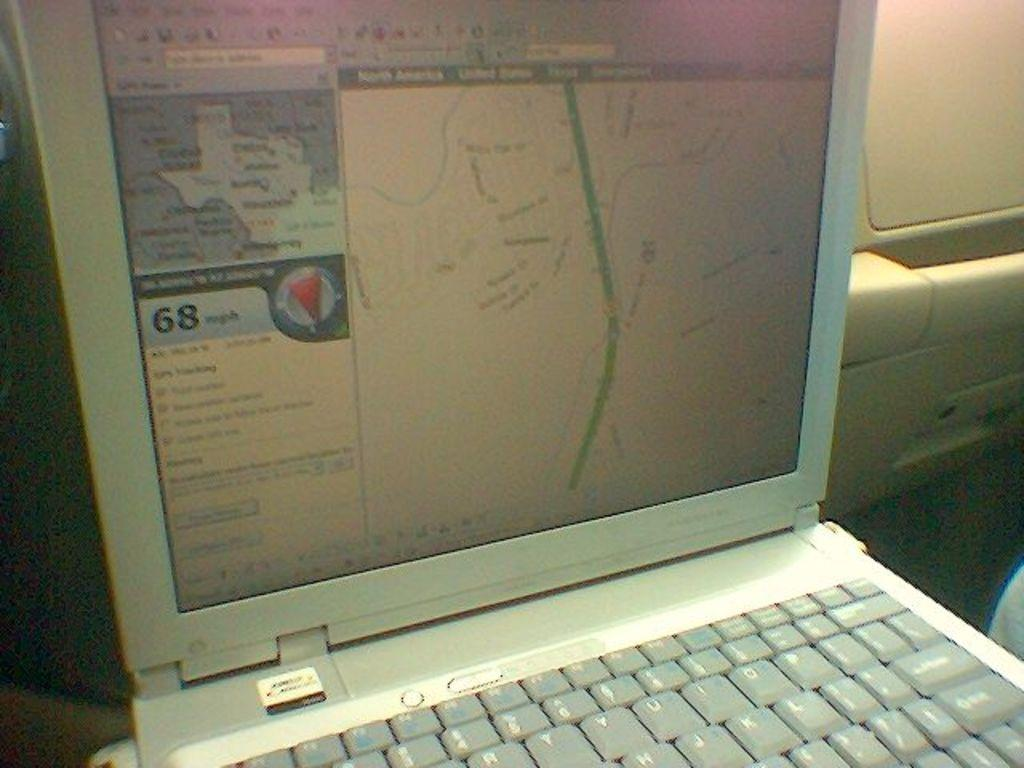Provide a one-sentence caption for the provided image. The laptop shows that the wind is 68 mph and is going south. 